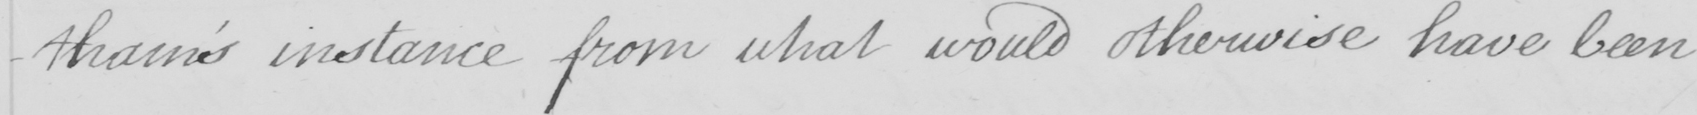Please transcribe the handwritten text in this image. -tham ' s instance from what would otherwise have been 